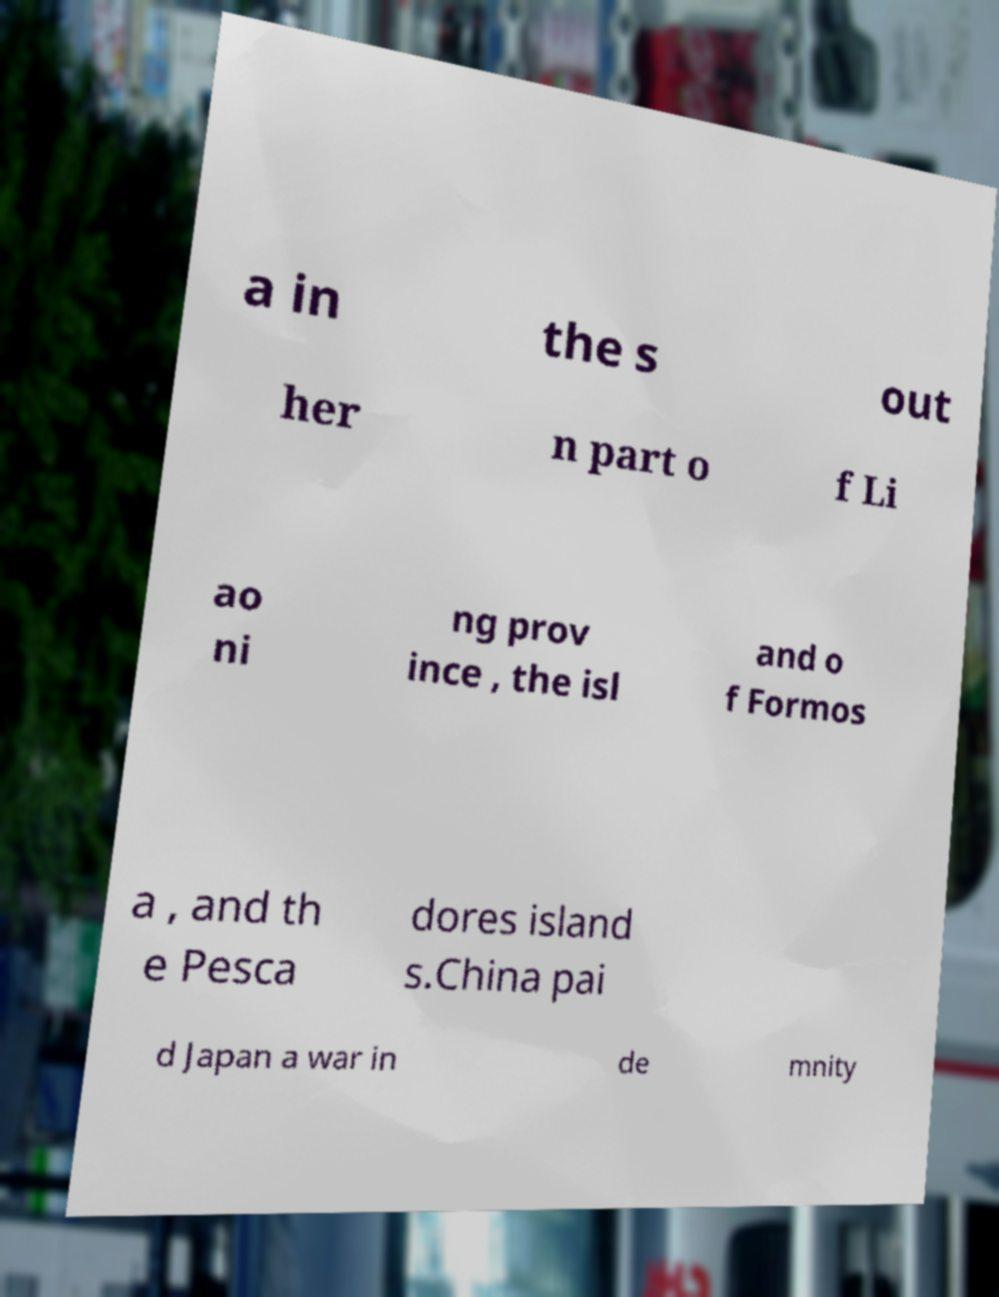What messages or text are displayed in this image? I need them in a readable, typed format. a in the s out her n part o f Li ao ni ng prov ince , the isl and o f Formos a , and th e Pesca dores island s.China pai d Japan a war in de mnity 